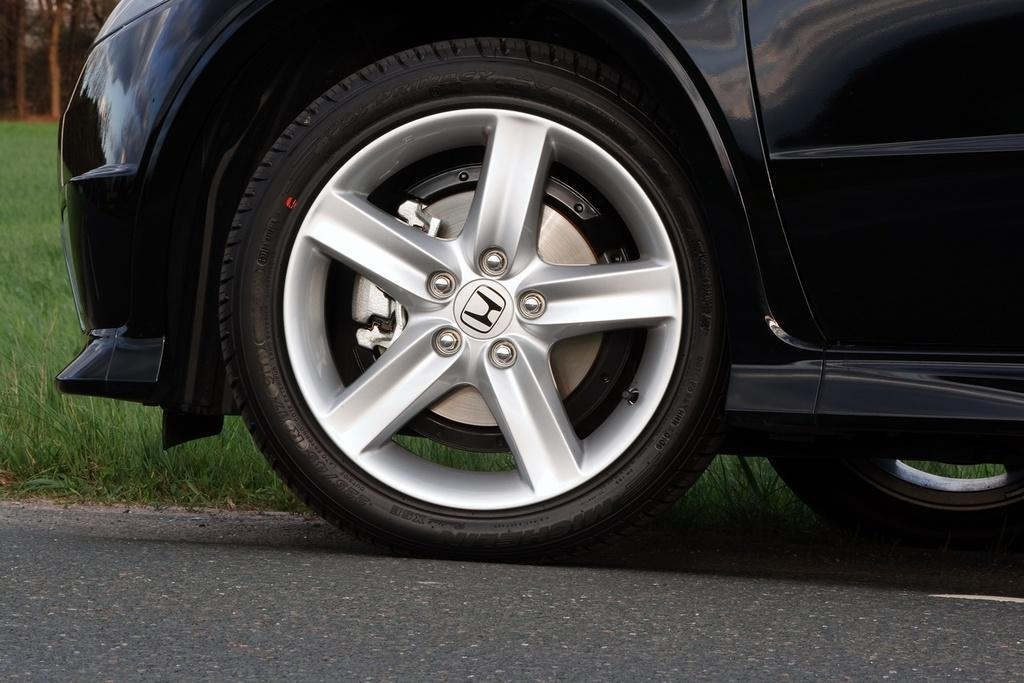What is the main subject of the image? There is a vehicle on the road in the image. Where is the vehicle located in the image? The vehicle is in the center of the image. What type of vegetation is visible beside the vehicle? There is grass beside the vehicle. Can you describe the background of the image? The background of the image is blurred. How does the vehicle lock itself in the image? The image does not show the vehicle locking itself; it only shows the vehicle on the road. What type of station is visible in the background of the image? There is no station visible in the background of the image. 